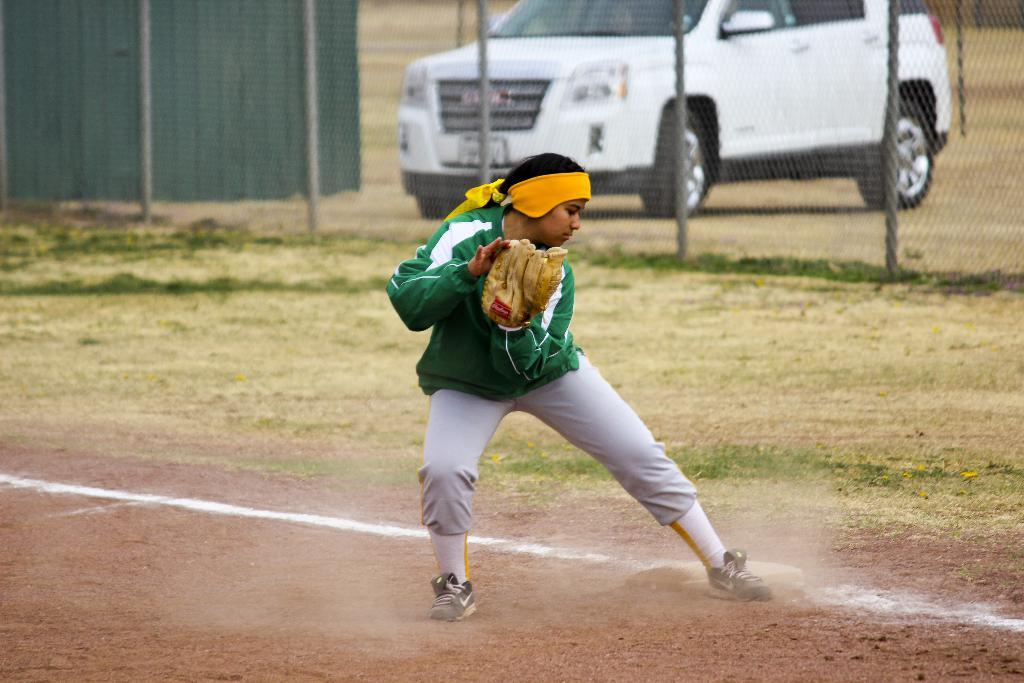What is the main subject of the image? There is a man standing in the image. What is the man wearing on his hands? The man is wearing gloves on his hands. What can be seen in the background of the image? There is mesh, a motor vehicle, and grass in the background of the image. What type of art can be seen on the motor vehicle in the image? There is no art visible on the motor vehicle in the image. What kind of music is the man playing in the image? There is no indication that the man is playing music in the image. 